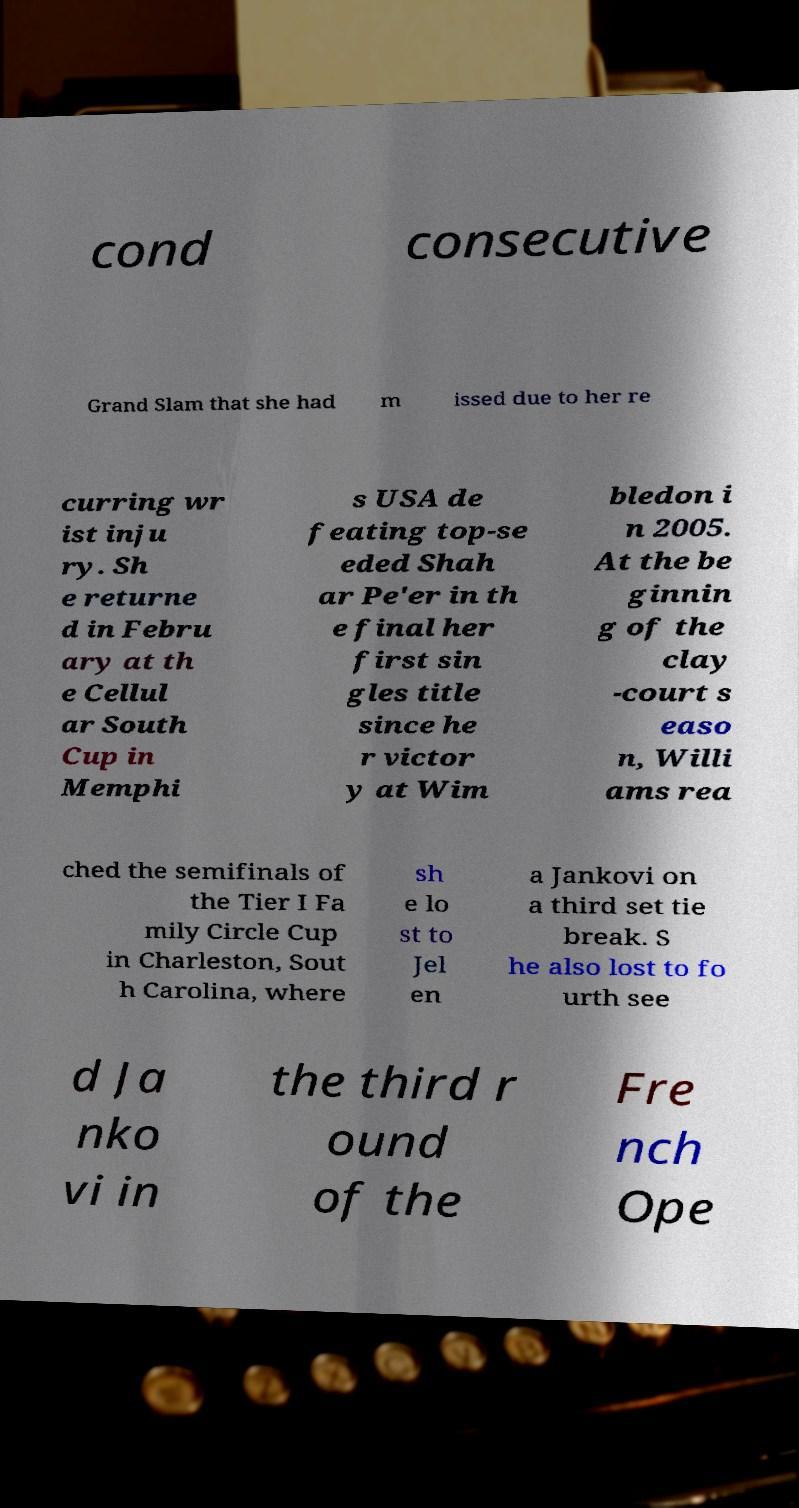For documentation purposes, I need the text within this image transcribed. Could you provide that? cond consecutive Grand Slam that she had m issed due to her re curring wr ist inju ry. Sh e returne d in Febru ary at th e Cellul ar South Cup in Memphi s USA de feating top-se eded Shah ar Pe'er in th e final her first sin gles title since he r victor y at Wim bledon i n 2005. At the be ginnin g of the clay -court s easo n, Willi ams rea ched the semifinals of the Tier I Fa mily Circle Cup in Charleston, Sout h Carolina, where sh e lo st to Jel en a Jankovi on a third set tie break. S he also lost to fo urth see d Ja nko vi in the third r ound of the Fre nch Ope 